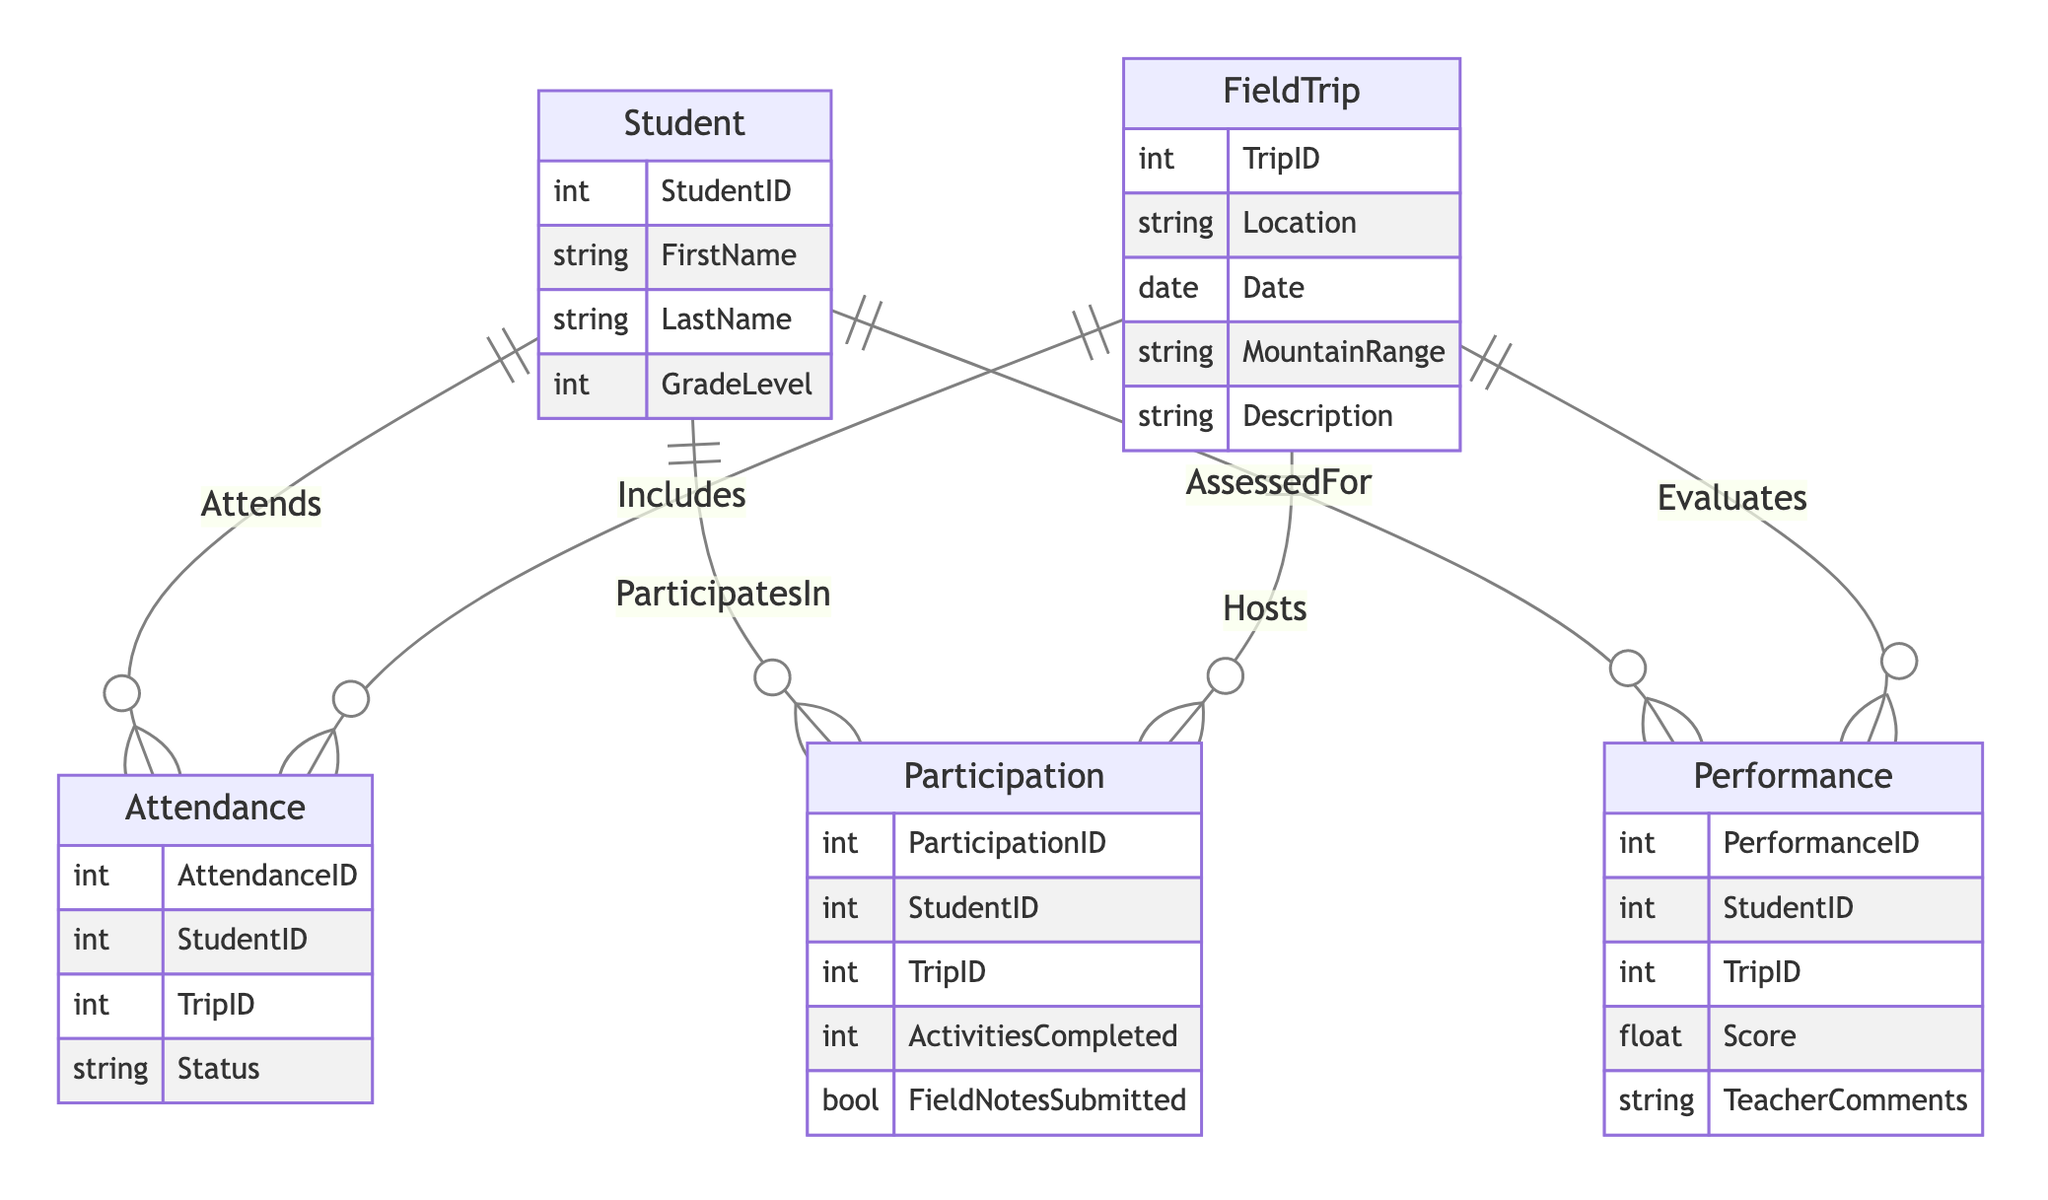What is the maximum number of students that can attend a single field trip? The diagram shows that there is a one-to-many relationship between Student and Attendance through the "Attends" relationship. Thus, multiple students can attend one field trip, but since the diagram doesn't specify limits, the number of students is not explicitly defined. However, since it's structurally designed to allow multiple entries, the answer is not limited to a specific number.
Answer: Unlimited How many entities are present in the diagram? The diagram lists five entities: Student, FieldTrip, Attendance, Participation, and Performance. By counting each unique entity in the provided data, we find a total of five.
Answer: Five What attribute does the Performance entity have that is used for assessment? The Performance entity contains the attribute "Score," which quantifies how well a student performed during the field trip. This directly ties to their assessment.
Answer: Score Which entity is related to both Attendance and Participation? The Student entity serves as the common link to both Attendance and Participation through its relationships "Attends" and "ParticipatesIn," showing its central role in both aspects of the field trips.
Answer: Student How many attributes does the FieldTrip entity contain? The FieldTrip entity includes five specific attributes: TripID, Location, Date, MountainRange, and Description. By counting these, we determine that there are five attributes total.
Answer: Five If a student participates but does not attend a field trip, how would this be reflected in the diagram? In the diagram, the relationships indicate that a student can exist in Participation without a corresponding Attendance if the "ParticipatesIn" relationship exists independently of "Attends." Therefore, this scenario is technically possible within the structure.
Answer: Possible What type of relationship exists between FieldTrip and Attendance? The relationship is a one-to-many from FieldTrip to Attendance. This implies that one field trip can have multiple attendance records associated with different students.
Answer: One-to-many Which entity might contain feedback on students' outdoor performance? The Performance entity is specifically designed to hold feedback and evaluation metrics for students, including attributes like "TeacherComments" for qualitative assessment.
Answer: Performance What is a common attribute found in both Participation and Attendance entities? Both entities include the attribute "StudentID," which serves to link them back to the Student entity, indicating which student is being referenced.
Answer: StudentID 